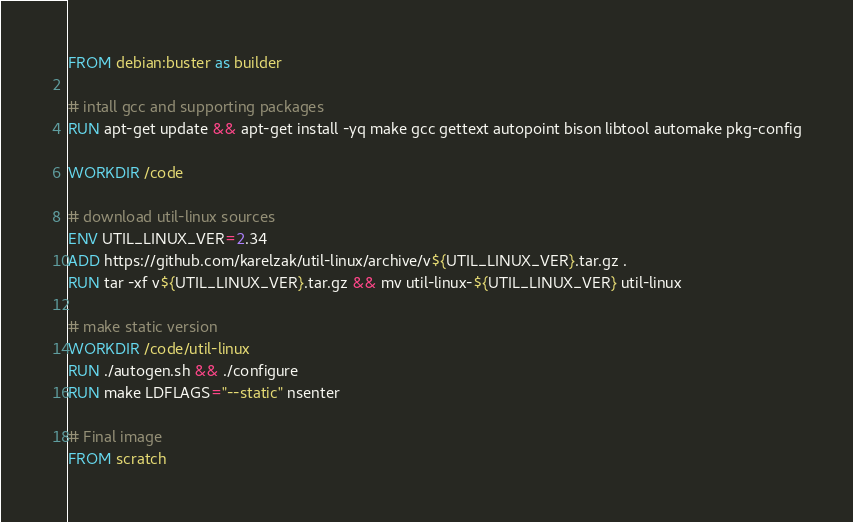<code> <loc_0><loc_0><loc_500><loc_500><_Dockerfile_>FROM debian:buster as builder

# intall gcc and supporting packages
RUN apt-get update && apt-get install -yq make gcc gettext autopoint bison libtool automake pkg-config

WORKDIR /code

# download util-linux sources
ENV UTIL_LINUX_VER=2.34
ADD https://github.com/karelzak/util-linux/archive/v${UTIL_LINUX_VER}.tar.gz .
RUN tar -xf v${UTIL_LINUX_VER}.tar.gz && mv util-linux-${UTIL_LINUX_VER} util-linux

# make static version
WORKDIR /code/util-linux
RUN ./autogen.sh && ./configure
RUN make LDFLAGS="--static" nsenter

# Final image
FROM scratch
</code> 